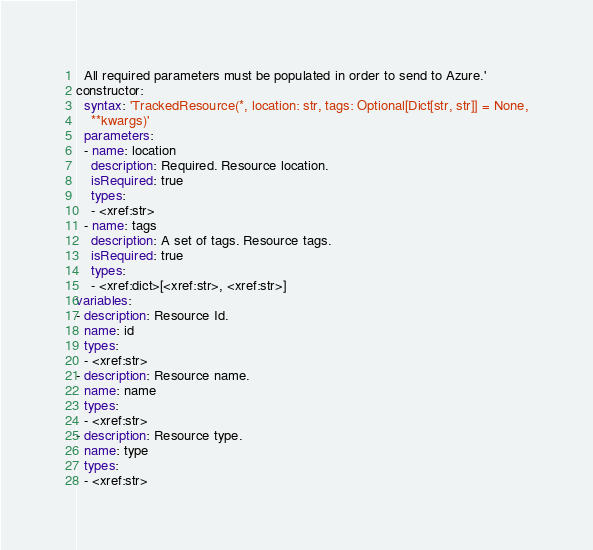Convert code to text. <code><loc_0><loc_0><loc_500><loc_500><_YAML_>  All required parameters must be populated in order to send to Azure.'
constructor:
  syntax: 'TrackedResource(*, location: str, tags: Optional[Dict[str, str]] = None,
    **kwargs)'
  parameters:
  - name: location
    description: Required. Resource location.
    isRequired: true
    types:
    - <xref:str>
  - name: tags
    description: A set of tags. Resource tags.
    isRequired: true
    types:
    - <xref:dict>[<xref:str>, <xref:str>]
variables:
- description: Resource Id.
  name: id
  types:
  - <xref:str>
- description: Resource name.
  name: name
  types:
  - <xref:str>
- description: Resource type.
  name: type
  types:
  - <xref:str>
</code> 